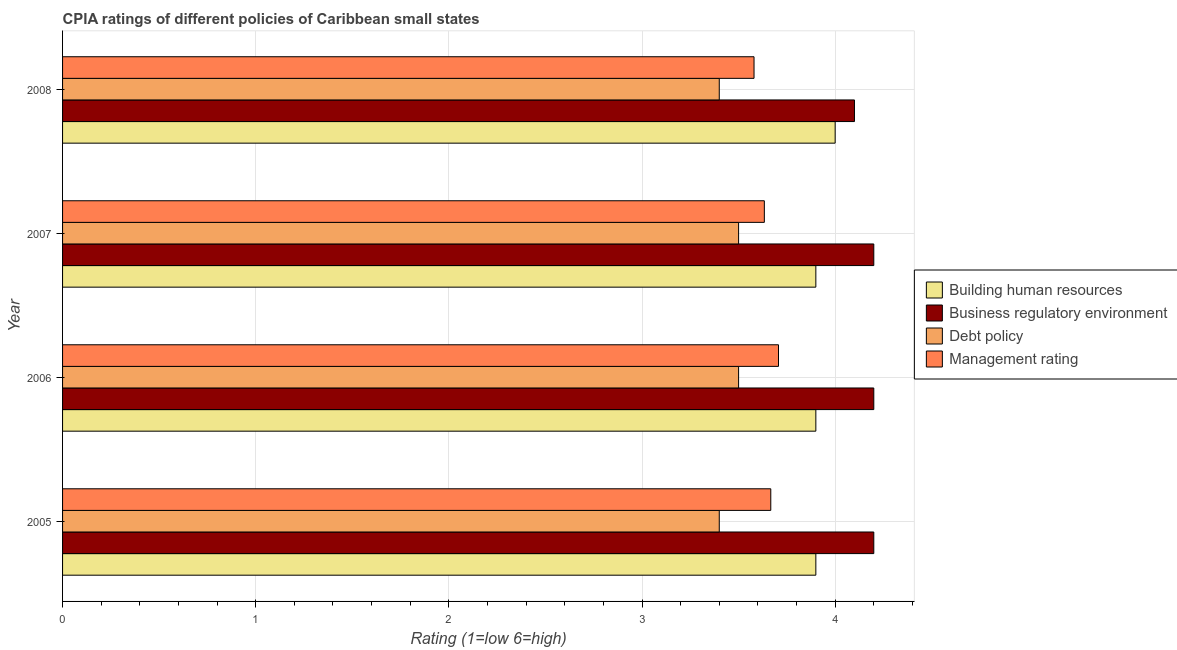How many different coloured bars are there?
Your answer should be very brief. 4. How many groups of bars are there?
Keep it short and to the point. 4. How many bars are there on the 3rd tick from the top?
Keep it short and to the point. 4. How many bars are there on the 3rd tick from the bottom?
Provide a succinct answer. 4. What is the label of the 1st group of bars from the top?
Give a very brief answer. 2008. What is the cpia rating of debt policy in 2006?
Offer a terse response. 3.5. Across all years, what is the maximum cpia rating of debt policy?
Your answer should be compact. 3.5. In which year was the cpia rating of debt policy maximum?
Offer a very short reply. 2006. In which year was the cpia rating of debt policy minimum?
Offer a terse response. 2005. What is the total cpia rating of debt policy in the graph?
Provide a short and direct response. 13.8. What is the difference between the cpia rating of business regulatory environment in 2008 and the cpia rating of management in 2005?
Give a very brief answer. 0.43. What is the average cpia rating of building human resources per year?
Offer a terse response. 3.92. In the year 2007, what is the difference between the cpia rating of business regulatory environment and cpia rating of building human resources?
Give a very brief answer. 0.3. In how many years, is the cpia rating of business regulatory environment greater than 0.8 ?
Provide a short and direct response. 4. Is the difference between the cpia rating of debt policy in 2006 and 2007 greater than the difference between the cpia rating of management in 2006 and 2007?
Provide a succinct answer. No. What is the difference between the highest and the lowest cpia rating of management?
Your response must be concise. 0.13. Is it the case that in every year, the sum of the cpia rating of business regulatory environment and cpia rating of management is greater than the sum of cpia rating of debt policy and cpia rating of building human resources?
Provide a succinct answer. Yes. What does the 3rd bar from the top in 2005 represents?
Give a very brief answer. Business regulatory environment. What does the 1st bar from the bottom in 2005 represents?
Keep it short and to the point. Building human resources. Is it the case that in every year, the sum of the cpia rating of building human resources and cpia rating of business regulatory environment is greater than the cpia rating of debt policy?
Offer a terse response. Yes. How many bars are there?
Offer a very short reply. 16. Are all the bars in the graph horizontal?
Make the answer very short. Yes. How many years are there in the graph?
Provide a succinct answer. 4. Does the graph contain grids?
Offer a very short reply. Yes. How many legend labels are there?
Keep it short and to the point. 4. How are the legend labels stacked?
Your response must be concise. Vertical. What is the title of the graph?
Keep it short and to the point. CPIA ratings of different policies of Caribbean small states. Does "Financial sector" appear as one of the legend labels in the graph?
Your answer should be compact. No. What is the label or title of the X-axis?
Offer a very short reply. Rating (1=low 6=high). What is the Rating (1=low 6=high) in Building human resources in 2005?
Ensure brevity in your answer.  3.9. What is the Rating (1=low 6=high) in Management rating in 2005?
Make the answer very short. 3.67. What is the Rating (1=low 6=high) in Building human resources in 2006?
Provide a succinct answer. 3.9. What is the Rating (1=low 6=high) in Business regulatory environment in 2006?
Your answer should be very brief. 4.2. What is the Rating (1=low 6=high) of Management rating in 2006?
Give a very brief answer. 3.71. What is the Rating (1=low 6=high) in Building human resources in 2007?
Your answer should be very brief. 3.9. What is the Rating (1=low 6=high) in Business regulatory environment in 2007?
Your answer should be compact. 4.2. What is the Rating (1=low 6=high) of Debt policy in 2007?
Make the answer very short. 3.5. What is the Rating (1=low 6=high) of Management rating in 2007?
Provide a succinct answer. 3.63. What is the Rating (1=low 6=high) in Building human resources in 2008?
Provide a short and direct response. 4. What is the Rating (1=low 6=high) in Business regulatory environment in 2008?
Ensure brevity in your answer.  4.1. What is the Rating (1=low 6=high) of Management rating in 2008?
Ensure brevity in your answer.  3.58. Across all years, what is the maximum Rating (1=low 6=high) of Building human resources?
Give a very brief answer. 4. Across all years, what is the maximum Rating (1=low 6=high) in Debt policy?
Provide a succinct answer. 3.5. Across all years, what is the maximum Rating (1=low 6=high) in Management rating?
Offer a terse response. 3.71. Across all years, what is the minimum Rating (1=low 6=high) of Building human resources?
Provide a succinct answer. 3.9. Across all years, what is the minimum Rating (1=low 6=high) in Business regulatory environment?
Make the answer very short. 4.1. Across all years, what is the minimum Rating (1=low 6=high) of Debt policy?
Your answer should be very brief. 3.4. Across all years, what is the minimum Rating (1=low 6=high) in Management rating?
Offer a very short reply. 3.58. What is the total Rating (1=low 6=high) in Building human resources in the graph?
Ensure brevity in your answer.  15.7. What is the total Rating (1=low 6=high) in Business regulatory environment in the graph?
Give a very brief answer. 16.7. What is the total Rating (1=low 6=high) of Management rating in the graph?
Your answer should be very brief. 14.59. What is the difference between the Rating (1=low 6=high) of Business regulatory environment in 2005 and that in 2006?
Provide a short and direct response. 0. What is the difference between the Rating (1=low 6=high) in Management rating in 2005 and that in 2006?
Your answer should be very brief. -0.04. What is the difference between the Rating (1=low 6=high) of Building human resources in 2005 and that in 2007?
Offer a terse response. 0. What is the difference between the Rating (1=low 6=high) in Business regulatory environment in 2005 and that in 2007?
Your response must be concise. 0. What is the difference between the Rating (1=low 6=high) in Business regulatory environment in 2005 and that in 2008?
Ensure brevity in your answer.  0.1. What is the difference between the Rating (1=low 6=high) of Debt policy in 2005 and that in 2008?
Offer a terse response. 0. What is the difference between the Rating (1=low 6=high) of Management rating in 2005 and that in 2008?
Make the answer very short. 0.09. What is the difference between the Rating (1=low 6=high) of Building human resources in 2006 and that in 2007?
Provide a short and direct response. 0. What is the difference between the Rating (1=low 6=high) of Management rating in 2006 and that in 2007?
Ensure brevity in your answer.  0.07. What is the difference between the Rating (1=low 6=high) in Business regulatory environment in 2006 and that in 2008?
Ensure brevity in your answer.  0.1. What is the difference between the Rating (1=low 6=high) in Debt policy in 2006 and that in 2008?
Provide a succinct answer. 0.1. What is the difference between the Rating (1=low 6=high) of Management rating in 2006 and that in 2008?
Make the answer very short. 0.13. What is the difference between the Rating (1=low 6=high) of Business regulatory environment in 2007 and that in 2008?
Provide a short and direct response. 0.1. What is the difference between the Rating (1=low 6=high) of Debt policy in 2007 and that in 2008?
Make the answer very short. 0.1. What is the difference between the Rating (1=low 6=high) of Management rating in 2007 and that in 2008?
Your answer should be very brief. 0.05. What is the difference between the Rating (1=low 6=high) in Building human resources in 2005 and the Rating (1=low 6=high) in Business regulatory environment in 2006?
Make the answer very short. -0.3. What is the difference between the Rating (1=low 6=high) in Building human resources in 2005 and the Rating (1=low 6=high) in Management rating in 2006?
Offer a very short reply. 0.19. What is the difference between the Rating (1=low 6=high) in Business regulatory environment in 2005 and the Rating (1=low 6=high) in Debt policy in 2006?
Provide a short and direct response. 0.7. What is the difference between the Rating (1=low 6=high) in Business regulatory environment in 2005 and the Rating (1=low 6=high) in Management rating in 2006?
Give a very brief answer. 0.49. What is the difference between the Rating (1=low 6=high) of Debt policy in 2005 and the Rating (1=low 6=high) of Management rating in 2006?
Provide a succinct answer. -0.31. What is the difference between the Rating (1=low 6=high) in Building human resources in 2005 and the Rating (1=low 6=high) in Business regulatory environment in 2007?
Offer a very short reply. -0.3. What is the difference between the Rating (1=low 6=high) in Building human resources in 2005 and the Rating (1=low 6=high) in Management rating in 2007?
Keep it short and to the point. 0.27. What is the difference between the Rating (1=low 6=high) in Business regulatory environment in 2005 and the Rating (1=low 6=high) in Management rating in 2007?
Offer a terse response. 0.57. What is the difference between the Rating (1=low 6=high) in Debt policy in 2005 and the Rating (1=low 6=high) in Management rating in 2007?
Make the answer very short. -0.23. What is the difference between the Rating (1=low 6=high) in Building human resources in 2005 and the Rating (1=low 6=high) in Debt policy in 2008?
Give a very brief answer. 0.5. What is the difference between the Rating (1=low 6=high) in Building human resources in 2005 and the Rating (1=low 6=high) in Management rating in 2008?
Provide a succinct answer. 0.32. What is the difference between the Rating (1=low 6=high) of Business regulatory environment in 2005 and the Rating (1=low 6=high) of Debt policy in 2008?
Keep it short and to the point. 0.8. What is the difference between the Rating (1=low 6=high) in Business regulatory environment in 2005 and the Rating (1=low 6=high) in Management rating in 2008?
Give a very brief answer. 0.62. What is the difference between the Rating (1=low 6=high) of Debt policy in 2005 and the Rating (1=low 6=high) of Management rating in 2008?
Keep it short and to the point. -0.18. What is the difference between the Rating (1=low 6=high) of Building human resources in 2006 and the Rating (1=low 6=high) of Management rating in 2007?
Offer a terse response. 0.27. What is the difference between the Rating (1=low 6=high) in Business regulatory environment in 2006 and the Rating (1=low 6=high) in Management rating in 2007?
Keep it short and to the point. 0.57. What is the difference between the Rating (1=low 6=high) of Debt policy in 2006 and the Rating (1=low 6=high) of Management rating in 2007?
Provide a succinct answer. -0.13. What is the difference between the Rating (1=low 6=high) in Building human resources in 2006 and the Rating (1=low 6=high) in Management rating in 2008?
Offer a very short reply. 0.32. What is the difference between the Rating (1=low 6=high) of Business regulatory environment in 2006 and the Rating (1=low 6=high) of Management rating in 2008?
Offer a very short reply. 0.62. What is the difference between the Rating (1=low 6=high) in Debt policy in 2006 and the Rating (1=low 6=high) in Management rating in 2008?
Your response must be concise. -0.08. What is the difference between the Rating (1=low 6=high) in Building human resources in 2007 and the Rating (1=low 6=high) in Management rating in 2008?
Keep it short and to the point. 0.32. What is the difference between the Rating (1=low 6=high) of Business regulatory environment in 2007 and the Rating (1=low 6=high) of Management rating in 2008?
Your answer should be very brief. 0.62. What is the difference between the Rating (1=low 6=high) of Debt policy in 2007 and the Rating (1=low 6=high) of Management rating in 2008?
Your answer should be very brief. -0.08. What is the average Rating (1=low 6=high) in Building human resources per year?
Offer a very short reply. 3.92. What is the average Rating (1=low 6=high) in Business regulatory environment per year?
Provide a short and direct response. 4.17. What is the average Rating (1=low 6=high) of Debt policy per year?
Offer a very short reply. 3.45. What is the average Rating (1=low 6=high) of Management rating per year?
Give a very brief answer. 3.65. In the year 2005, what is the difference between the Rating (1=low 6=high) of Building human resources and Rating (1=low 6=high) of Debt policy?
Offer a very short reply. 0.5. In the year 2005, what is the difference between the Rating (1=low 6=high) of Building human resources and Rating (1=low 6=high) of Management rating?
Provide a succinct answer. 0.23. In the year 2005, what is the difference between the Rating (1=low 6=high) in Business regulatory environment and Rating (1=low 6=high) in Debt policy?
Give a very brief answer. 0.8. In the year 2005, what is the difference between the Rating (1=low 6=high) of Business regulatory environment and Rating (1=low 6=high) of Management rating?
Ensure brevity in your answer.  0.53. In the year 2005, what is the difference between the Rating (1=low 6=high) of Debt policy and Rating (1=low 6=high) of Management rating?
Provide a short and direct response. -0.27. In the year 2006, what is the difference between the Rating (1=low 6=high) in Building human resources and Rating (1=low 6=high) in Management rating?
Offer a very short reply. 0.19. In the year 2006, what is the difference between the Rating (1=low 6=high) in Business regulatory environment and Rating (1=low 6=high) in Management rating?
Offer a terse response. 0.49. In the year 2006, what is the difference between the Rating (1=low 6=high) in Debt policy and Rating (1=low 6=high) in Management rating?
Keep it short and to the point. -0.21. In the year 2007, what is the difference between the Rating (1=low 6=high) of Building human resources and Rating (1=low 6=high) of Business regulatory environment?
Give a very brief answer. -0.3. In the year 2007, what is the difference between the Rating (1=low 6=high) of Building human resources and Rating (1=low 6=high) of Management rating?
Offer a very short reply. 0.27. In the year 2007, what is the difference between the Rating (1=low 6=high) in Business regulatory environment and Rating (1=low 6=high) in Management rating?
Give a very brief answer. 0.57. In the year 2007, what is the difference between the Rating (1=low 6=high) in Debt policy and Rating (1=low 6=high) in Management rating?
Your answer should be very brief. -0.13. In the year 2008, what is the difference between the Rating (1=low 6=high) in Building human resources and Rating (1=low 6=high) in Business regulatory environment?
Make the answer very short. -0.1. In the year 2008, what is the difference between the Rating (1=low 6=high) of Building human resources and Rating (1=low 6=high) of Management rating?
Keep it short and to the point. 0.42. In the year 2008, what is the difference between the Rating (1=low 6=high) in Business regulatory environment and Rating (1=low 6=high) in Management rating?
Offer a terse response. 0.52. In the year 2008, what is the difference between the Rating (1=low 6=high) of Debt policy and Rating (1=low 6=high) of Management rating?
Your answer should be very brief. -0.18. What is the ratio of the Rating (1=low 6=high) in Building human resources in 2005 to that in 2006?
Make the answer very short. 1. What is the ratio of the Rating (1=low 6=high) of Debt policy in 2005 to that in 2006?
Your answer should be very brief. 0.97. What is the ratio of the Rating (1=low 6=high) in Management rating in 2005 to that in 2006?
Your response must be concise. 0.99. What is the ratio of the Rating (1=low 6=high) of Building human resources in 2005 to that in 2007?
Your response must be concise. 1. What is the ratio of the Rating (1=low 6=high) in Debt policy in 2005 to that in 2007?
Give a very brief answer. 0.97. What is the ratio of the Rating (1=low 6=high) of Management rating in 2005 to that in 2007?
Give a very brief answer. 1.01. What is the ratio of the Rating (1=low 6=high) of Business regulatory environment in 2005 to that in 2008?
Offer a very short reply. 1.02. What is the ratio of the Rating (1=low 6=high) of Management rating in 2005 to that in 2008?
Provide a succinct answer. 1.02. What is the ratio of the Rating (1=low 6=high) of Management rating in 2006 to that in 2007?
Give a very brief answer. 1.02. What is the ratio of the Rating (1=low 6=high) of Building human resources in 2006 to that in 2008?
Your response must be concise. 0.97. What is the ratio of the Rating (1=low 6=high) of Business regulatory environment in 2006 to that in 2008?
Provide a short and direct response. 1.02. What is the ratio of the Rating (1=low 6=high) in Debt policy in 2006 to that in 2008?
Your response must be concise. 1.03. What is the ratio of the Rating (1=low 6=high) in Management rating in 2006 to that in 2008?
Provide a short and direct response. 1.04. What is the ratio of the Rating (1=low 6=high) of Building human resources in 2007 to that in 2008?
Offer a very short reply. 0.97. What is the ratio of the Rating (1=low 6=high) in Business regulatory environment in 2007 to that in 2008?
Offer a very short reply. 1.02. What is the ratio of the Rating (1=low 6=high) in Debt policy in 2007 to that in 2008?
Offer a terse response. 1.03. What is the ratio of the Rating (1=low 6=high) of Management rating in 2007 to that in 2008?
Your answer should be very brief. 1.01. What is the difference between the highest and the second highest Rating (1=low 6=high) of Building human resources?
Provide a succinct answer. 0.1. What is the difference between the highest and the second highest Rating (1=low 6=high) in Business regulatory environment?
Your answer should be very brief. 0. What is the difference between the highest and the second highest Rating (1=low 6=high) in Management rating?
Ensure brevity in your answer.  0.04. What is the difference between the highest and the lowest Rating (1=low 6=high) of Debt policy?
Provide a succinct answer. 0.1. What is the difference between the highest and the lowest Rating (1=low 6=high) in Management rating?
Offer a very short reply. 0.13. 